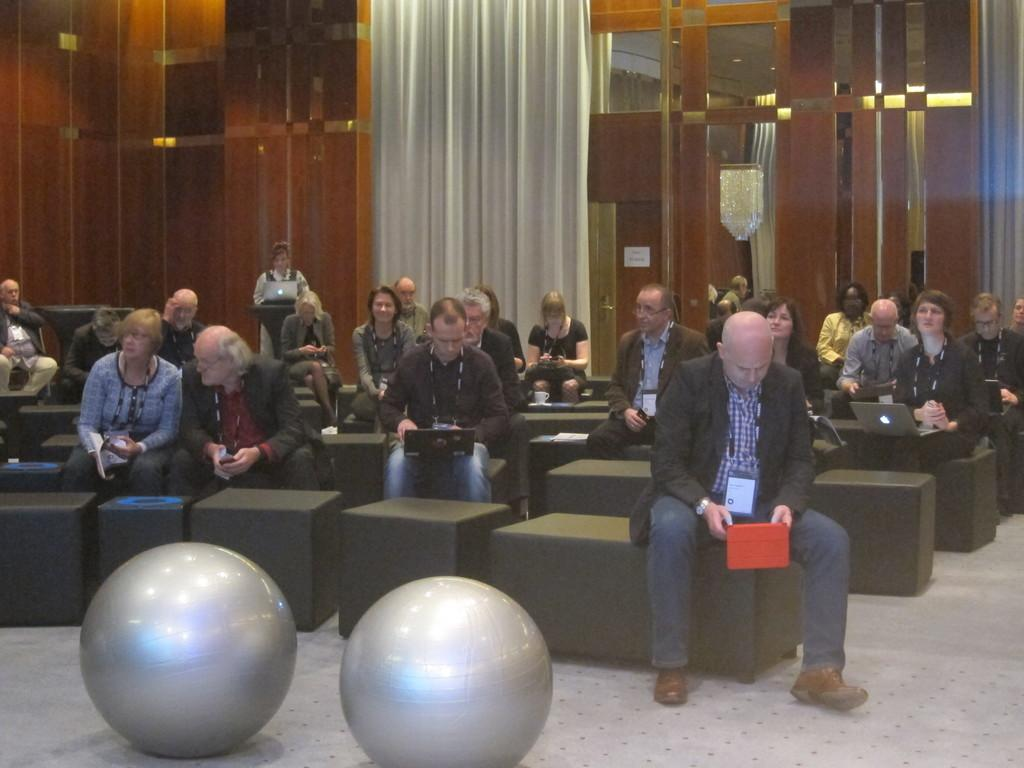How many people are in the image? There is a group of people in the image, but the exact number is not specified. What are the people in the image doing? Some people are seated, while others are standing. What can be seen in front of the group? There are balloons in front of the group. What is visible in the background of the image? There are curtains and lights visible in the background. What type of design can be seen on the fan in the image? There is no fan present in the image; it only features a group of people, balloons, curtains, and lights. 